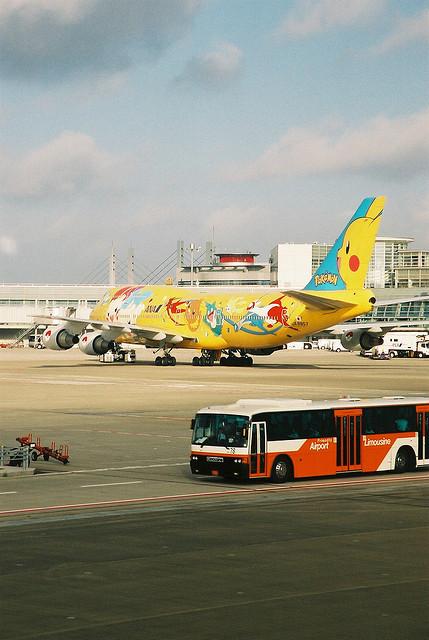Is the picture up close?
Keep it brief. No. Where is pokemon?
Write a very short answer. On plane. Is that plane flying?
Keep it brief. No. 